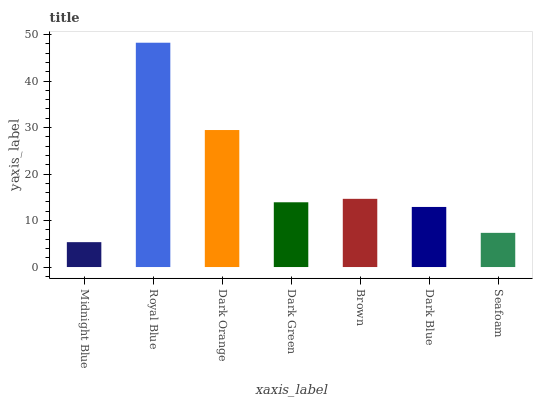Is Dark Orange the minimum?
Answer yes or no. No. Is Dark Orange the maximum?
Answer yes or no. No. Is Royal Blue greater than Dark Orange?
Answer yes or no. Yes. Is Dark Orange less than Royal Blue?
Answer yes or no. Yes. Is Dark Orange greater than Royal Blue?
Answer yes or no. No. Is Royal Blue less than Dark Orange?
Answer yes or no. No. Is Dark Green the high median?
Answer yes or no. Yes. Is Dark Green the low median?
Answer yes or no. Yes. Is Brown the high median?
Answer yes or no. No. Is Royal Blue the low median?
Answer yes or no. No. 